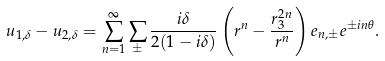Convert formula to latex. <formula><loc_0><loc_0><loc_500><loc_500>u _ { 1 , \delta } - u _ { 2 , \delta } = \sum _ { n = 1 } ^ { \infty } \sum _ { \pm } \frac { i \delta } { 2 ( 1 - i \delta ) } \left ( r ^ { n } - \frac { r _ { 3 } ^ { 2 n } } { r ^ { n } } \right ) e _ { n , \pm } e ^ { \pm i n \theta } .</formula> 